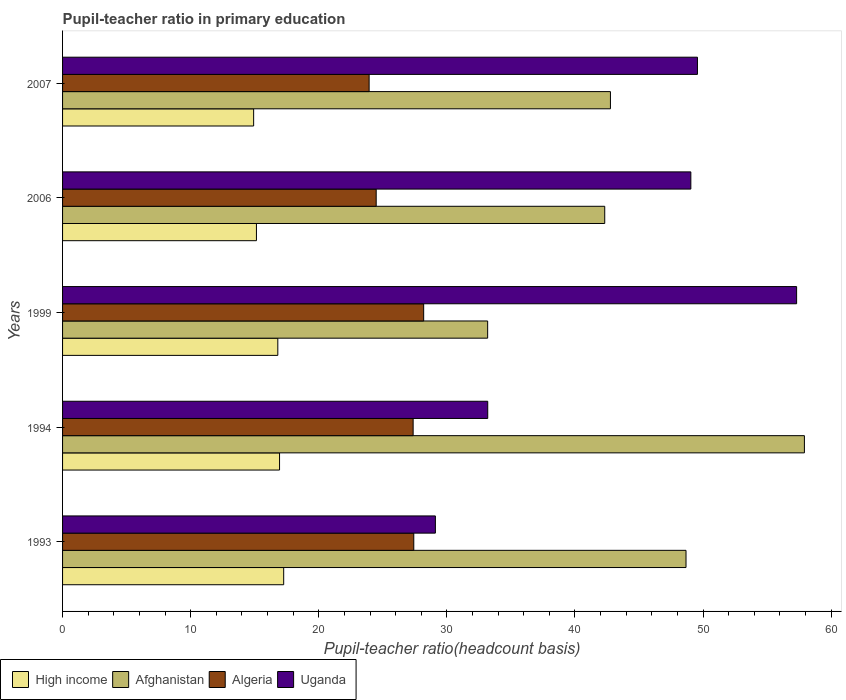How many different coloured bars are there?
Keep it short and to the point. 4. How many groups of bars are there?
Give a very brief answer. 5. What is the label of the 4th group of bars from the top?
Your answer should be very brief. 1994. In how many cases, is the number of bars for a given year not equal to the number of legend labels?
Your answer should be very brief. 0. What is the pupil-teacher ratio in primary education in High income in 2007?
Your answer should be very brief. 14.92. Across all years, what is the maximum pupil-teacher ratio in primary education in Afghanistan?
Your answer should be compact. 57.91. Across all years, what is the minimum pupil-teacher ratio in primary education in Uganda?
Keep it short and to the point. 29.11. In which year was the pupil-teacher ratio in primary education in Algeria maximum?
Your answer should be compact. 1999. In which year was the pupil-teacher ratio in primary education in Afghanistan minimum?
Offer a very short reply. 1999. What is the total pupil-teacher ratio in primary education in Uganda in the graph?
Provide a succinct answer. 218.21. What is the difference between the pupil-teacher ratio in primary education in Uganda in 1994 and that in 2006?
Your answer should be compact. -15.86. What is the difference between the pupil-teacher ratio in primary education in Uganda in 1993 and the pupil-teacher ratio in primary education in Algeria in 2007?
Offer a terse response. 5.17. What is the average pupil-teacher ratio in primary education in High income per year?
Your response must be concise. 16.21. In the year 2007, what is the difference between the pupil-teacher ratio in primary education in Uganda and pupil-teacher ratio in primary education in High income?
Make the answer very short. 34.65. What is the ratio of the pupil-teacher ratio in primary education in High income in 1994 to that in 2006?
Your answer should be very brief. 1.12. What is the difference between the highest and the second highest pupil-teacher ratio in primary education in High income?
Offer a terse response. 0.32. What is the difference between the highest and the lowest pupil-teacher ratio in primary education in High income?
Give a very brief answer. 2.35. Is the sum of the pupil-teacher ratio in primary education in Algeria in 1994 and 1999 greater than the maximum pupil-teacher ratio in primary education in Uganda across all years?
Your answer should be compact. No. Is it the case that in every year, the sum of the pupil-teacher ratio in primary education in High income and pupil-teacher ratio in primary education in Uganda is greater than the sum of pupil-teacher ratio in primary education in Algeria and pupil-teacher ratio in primary education in Afghanistan?
Your response must be concise. Yes. What does the 1st bar from the top in 1993 represents?
Your response must be concise. Uganda. What does the 1st bar from the bottom in 2007 represents?
Give a very brief answer. High income. Is it the case that in every year, the sum of the pupil-teacher ratio in primary education in Algeria and pupil-teacher ratio in primary education in Afghanistan is greater than the pupil-teacher ratio in primary education in High income?
Your answer should be compact. Yes. How many bars are there?
Offer a very short reply. 20. Are all the bars in the graph horizontal?
Offer a terse response. Yes. What is the difference between two consecutive major ticks on the X-axis?
Your answer should be compact. 10. Are the values on the major ticks of X-axis written in scientific E-notation?
Offer a very short reply. No. Does the graph contain any zero values?
Make the answer very short. No. Does the graph contain grids?
Your answer should be compact. No. How many legend labels are there?
Provide a succinct answer. 4. How are the legend labels stacked?
Provide a short and direct response. Horizontal. What is the title of the graph?
Give a very brief answer. Pupil-teacher ratio in primary education. What is the label or title of the X-axis?
Provide a short and direct response. Pupil-teacher ratio(headcount basis). What is the label or title of the Y-axis?
Keep it short and to the point. Years. What is the Pupil-teacher ratio(headcount basis) of High income in 1993?
Provide a short and direct response. 17.26. What is the Pupil-teacher ratio(headcount basis) of Afghanistan in 1993?
Your answer should be very brief. 48.67. What is the Pupil-teacher ratio(headcount basis) in Algeria in 1993?
Give a very brief answer. 27.42. What is the Pupil-teacher ratio(headcount basis) in Uganda in 1993?
Provide a succinct answer. 29.11. What is the Pupil-teacher ratio(headcount basis) in High income in 1994?
Offer a terse response. 16.94. What is the Pupil-teacher ratio(headcount basis) of Afghanistan in 1994?
Ensure brevity in your answer.  57.91. What is the Pupil-teacher ratio(headcount basis) in Algeria in 1994?
Provide a short and direct response. 27.37. What is the Pupil-teacher ratio(headcount basis) of Uganda in 1994?
Offer a very short reply. 33.19. What is the Pupil-teacher ratio(headcount basis) in High income in 1999?
Your answer should be compact. 16.8. What is the Pupil-teacher ratio(headcount basis) in Afghanistan in 1999?
Offer a terse response. 33.19. What is the Pupil-teacher ratio(headcount basis) of Algeria in 1999?
Keep it short and to the point. 28.19. What is the Pupil-teacher ratio(headcount basis) in Uganda in 1999?
Offer a very short reply. 57.3. What is the Pupil-teacher ratio(headcount basis) in High income in 2006?
Offer a terse response. 15.14. What is the Pupil-teacher ratio(headcount basis) in Afghanistan in 2006?
Make the answer very short. 42.33. What is the Pupil-teacher ratio(headcount basis) in Algeria in 2006?
Ensure brevity in your answer.  24.48. What is the Pupil-teacher ratio(headcount basis) in Uganda in 2006?
Give a very brief answer. 49.05. What is the Pupil-teacher ratio(headcount basis) in High income in 2007?
Provide a succinct answer. 14.92. What is the Pupil-teacher ratio(headcount basis) of Afghanistan in 2007?
Keep it short and to the point. 42.77. What is the Pupil-teacher ratio(headcount basis) of Algeria in 2007?
Offer a terse response. 23.93. What is the Pupil-teacher ratio(headcount basis) of Uganda in 2007?
Give a very brief answer. 49.56. Across all years, what is the maximum Pupil-teacher ratio(headcount basis) in High income?
Your answer should be very brief. 17.26. Across all years, what is the maximum Pupil-teacher ratio(headcount basis) in Afghanistan?
Keep it short and to the point. 57.91. Across all years, what is the maximum Pupil-teacher ratio(headcount basis) of Algeria?
Provide a short and direct response. 28.19. Across all years, what is the maximum Pupil-teacher ratio(headcount basis) in Uganda?
Provide a short and direct response. 57.3. Across all years, what is the minimum Pupil-teacher ratio(headcount basis) of High income?
Provide a succinct answer. 14.92. Across all years, what is the minimum Pupil-teacher ratio(headcount basis) of Afghanistan?
Your answer should be compact. 33.19. Across all years, what is the minimum Pupil-teacher ratio(headcount basis) of Algeria?
Give a very brief answer. 23.93. Across all years, what is the minimum Pupil-teacher ratio(headcount basis) in Uganda?
Offer a very short reply. 29.11. What is the total Pupil-teacher ratio(headcount basis) of High income in the graph?
Offer a very short reply. 81.06. What is the total Pupil-teacher ratio(headcount basis) in Afghanistan in the graph?
Your answer should be compact. 224.87. What is the total Pupil-teacher ratio(headcount basis) in Algeria in the graph?
Your response must be concise. 131.39. What is the total Pupil-teacher ratio(headcount basis) in Uganda in the graph?
Give a very brief answer. 218.21. What is the difference between the Pupil-teacher ratio(headcount basis) of High income in 1993 and that in 1994?
Make the answer very short. 0.32. What is the difference between the Pupil-teacher ratio(headcount basis) of Afghanistan in 1993 and that in 1994?
Your response must be concise. -9.24. What is the difference between the Pupil-teacher ratio(headcount basis) of Algeria in 1993 and that in 1994?
Keep it short and to the point. 0.05. What is the difference between the Pupil-teacher ratio(headcount basis) of Uganda in 1993 and that in 1994?
Offer a very short reply. -4.09. What is the difference between the Pupil-teacher ratio(headcount basis) in High income in 1993 and that in 1999?
Give a very brief answer. 0.46. What is the difference between the Pupil-teacher ratio(headcount basis) of Afghanistan in 1993 and that in 1999?
Your response must be concise. 15.49. What is the difference between the Pupil-teacher ratio(headcount basis) in Algeria in 1993 and that in 1999?
Your answer should be very brief. -0.77. What is the difference between the Pupil-teacher ratio(headcount basis) of Uganda in 1993 and that in 1999?
Your answer should be compact. -28.2. What is the difference between the Pupil-teacher ratio(headcount basis) in High income in 1993 and that in 2006?
Your answer should be compact. 2.13. What is the difference between the Pupil-teacher ratio(headcount basis) of Afghanistan in 1993 and that in 2006?
Provide a succinct answer. 6.35. What is the difference between the Pupil-teacher ratio(headcount basis) in Algeria in 1993 and that in 2006?
Keep it short and to the point. 2.93. What is the difference between the Pupil-teacher ratio(headcount basis) in Uganda in 1993 and that in 2006?
Your answer should be very brief. -19.94. What is the difference between the Pupil-teacher ratio(headcount basis) in High income in 1993 and that in 2007?
Offer a terse response. 2.35. What is the difference between the Pupil-teacher ratio(headcount basis) of Afghanistan in 1993 and that in 2007?
Keep it short and to the point. 5.9. What is the difference between the Pupil-teacher ratio(headcount basis) of Algeria in 1993 and that in 2007?
Provide a short and direct response. 3.49. What is the difference between the Pupil-teacher ratio(headcount basis) of Uganda in 1993 and that in 2007?
Keep it short and to the point. -20.46. What is the difference between the Pupil-teacher ratio(headcount basis) in High income in 1994 and that in 1999?
Give a very brief answer. 0.14. What is the difference between the Pupil-teacher ratio(headcount basis) in Afghanistan in 1994 and that in 1999?
Make the answer very short. 24.73. What is the difference between the Pupil-teacher ratio(headcount basis) of Algeria in 1994 and that in 1999?
Offer a terse response. -0.82. What is the difference between the Pupil-teacher ratio(headcount basis) of Uganda in 1994 and that in 1999?
Your answer should be very brief. -24.11. What is the difference between the Pupil-teacher ratio(headcount basis) of High income in 1994 and that in 2006?
Your answer should be compact. 1.8. What is the difference between the Pupil-teacher ratio(headcount basis) of Afghanistan in 1994 and that in 2006?
Provide a short and direct response. 15.59. What is the difference between the Pupil-teacher ratio(headcount basis) of Algeria in 1994 and that in 2006?
Provide a succinct answer. 2.88. What is the difference between the Pupil-teacher ratio(headcount basis) of Uganda in 1994 and that in 2006?
Provide a short and direct response. -15.86. What is the difference between the Pupil-teacher ratio(headcount basis) of High income in 1994 and that in 2007?
Ensure brevity in your answer.  2.02. What is the difference between the Pupil-teacher ratio(headcount basis) of Afghanistan in 1994 and that in 2007?
Offer a terse response. 15.14. What is the difference between the Pupil-teacher ratio(headcount basis) of Algeria in 1994 and that in 2007?
Your response must be concise. 3.44. What is the difference between the Pupil-teacher ratio(headcount basis) in Uganda in 1994 and that in 2007?
Your response must be concise. -16.37. What is the difference between the Pupil-teacher ratio(headcount basis) of High income in 1999 and that in 2006?
Make the answer very short. 1.67. What is the difference between the Pupil-teacher ratio(headcount basis) in Afghanistan in 1999 and that in 2006?
Provide a succinct answer. -9.14. What is the difference between the Pupil-teacher ratio(headcount basis) of Algeria in 1999 and that in 2006?
Make the answer very short. 3.71. What is the difference between the Pupil-teacher ratio(headcount basis) of Uganda in 1999 and that in 2006?
Keep it short and to the point. 8.26. What is the difference between the Pupil-teacher ratio(headcount basis) of High income in 1999 and that in 2007?
Your response must be concise. 1.89. What is the difference between the Pupil-teacher ratio(headcount basis) of Afghanistan in 1999 and that in 2007?
Offer a terse response. -9.58. What is the difference between the Pupil-teacher ratio(headcount basis) in Algeria in 1999 and that in 2007?
Keep it short and to the point. 4.26. What is the difference between the Pupil-teacher ratio(headcount basis) in Uganda in 1999 and that in 2007?
Provide a short and direct response. 7.74. What is the difference between the Pupil-teacher ratio(headcount basis) of High income in 2006 and that in 2007?
Ensure brevity in your answer.  0.22. What is the difference between the Pupil-teacher ratio(headcount basis) of Afghanistan in 2006 and that in 2007?
Offer a terse response. -0.44. What is the difference between the Pupil-teacher ratio(headcount basis) of Algeria in 2006 and that in 2007?
Offer a very short reply. 0.55. What is the difference between the Pupil-teacher ratio(headcount basis) of Uganda in 2006 and that in 2007?
Your response must be concise. -0.52. What is the difference between the Pupil-teacher ratio(headcount basis) of High income in 1993 and the Pupil-teacher ratio(headcount basis) of Afghanistan in 1994?
Offer a terse response. -40.65. What is the difference between the Pupil-teacher ratio(headcount basis) of High income in 1993 and the Pupil-teacher ratio(headcount basis) of Algeria in 1994?
Keep it short and to the point. -10.11. What is the difference between the Pupil-teacher ratio(headcount basis) in High income in 1993 and the Pupil-teacher ratio(headcount basis) in Uganda in 1994?
Offer a very short reply. -15.93. What is the difference between the Pupil-teacher ratio(headcount basis) of Afghanistan in 1993 and the Pupil-teacher ratio(headcount basis) of Algeria in 1994?
Offer a very short reply. 21.3. What is the difference between the Pupil-teacher ratio(headcount basis) of Afghanistan in 1993 and the Pupil-teacher ratio(headcount basis) of Uganda in 1994?
Your response must be concise. 15.48. What is the difference between the Pupil-teacher ratio(headcount basis) of Algeria in 1993 and the Pupil-teacher ratio(headcount basis) of Uganda in 1994?
Your response must be concise. -5.77. What is the difference between the Pupil-teacher ratio(headcount basis) in High income in 1993 and the Pupil-teacher ratio(headcount basis) in Afghanistan in 1999?
Offer a very short reply. -15.92. What is the difference between the Pupil-teacher ratio(headcount basis) of High income in 1993 and the Pupil-teacher ratio(headcount basis) of Algeria in 1999?
Ensure brevity in your answer.  -10.93. What is the difference between the Pupil-teacher ratio(headcount basis) of High income in 1993 and the Pupil-teacher ratio(headcount basis) of Uganda in 1999?
Offer a terse response. -40.04. What is the difference between the Pupil-teacher ratio(headcount basis) in Afghanistan in 1993 and the Pupil-teacher ratio(headcount basis) in Algeria in 1999?
Make the answer very short. 20.48. What is the difference between the Pupil-teacher ratio(headcount basis) of Afghanistan in 1993 and the Pupil-teacher ratio(headcount basis) of Uganda in 1999?
Give a very brief answer. -8.63. What is the difference between the Pupil-teacher ratio(headcount basis) of Algeria in 1993 and the Pupil-teacher ratio(headcount basis) of Uganda in 1999?
Keep it short and to the point. -29.89. What is the difference between the Pupil-teacher ratio(headcount basis) in High income in 1993 and the Pupil-teacher ratio(headcount basis) in Afghanistan in 2006?
Provide a short and direct response. -25.06. What is the difference between the Pupil-teacher ratio(headcount basis) in High income in 1993 and the Pupil-teacher ratio(headcount basis) in Algeria in 2006?
Your response must be concise. -7.22. What is the difference between the Pupil-teacher ratio(headcount basis) of High income in 1993 and the Pupil-teacher ratio(headcount basis) of Uganda in 2006?
Your response must be concise. -31.78. What is the difference between the Pupil-teacher ratio(headcount basis) of Afghanistan in 1993 and the Pupil-teacher ratio(headcount basis) of Algeria in 2006?
Your answer should be very brief. 24.19. What is the difference between the Pupil-teacher ratio(headcount basis) in Afghanistan in 1993 and the Pupil-teacher ratio(headcount basis) in Uganda in 2006?
Ensure brevity in your answer.  -0.38. What is the difference between the Pupil-teacher ratio(headcount basis) of Algeria in 1993 and the Pupil-teacher ratio(headcount basis) of Uganda in 2006?
Ensure brevity in your answer.  -21.63. What is the difference between the Pupil-teacher ratio(headcount basis) of High income in 1993 and the Pupil-teacher ratio(headcount basis) of Afghanistan in 2007?
Your response must be concise. -25.51. What is the difference between the Pupil-teacher ratio(headcount basis) of High income in 1993 and the Pupil-teacher ratio(headcount basis) of Algeria in 2007?
Your response must be concise. -6.67. What is the difference between the Pupil-teacher ratio(headcount basis) of High income in 1993 and the Pupil-teacher ratio(headcount basis) of Uganda in 2007?
Give a very brief answer. -32.3. What is the difference between the Pupil-teacher ratio(headcount basis) of Afghanistan in 1993 and the Pupil-teacher ratio(headcount basis) of Algeria in 2007?
Your answer should be compact. 24.74. What is the difference between the Pupil-teacher ratio(headcount basis) in Afghanistan in 1993 and the Pupil-teacher ratio(headcount basis) in Uganda in 2007?
Offer a very short reply. -0.89. What is the difference between the Pupil-teacher ratio(headcount basis) of Algeria in 1993 and the Pupil-teacher ratio(headcount basis) of Uganda in 2007?
Offer a terse response. -22.15. What is the difference between the Pupil-teacher ratio(headcount basis) of High income in 1994 and the Pupil-teacher ratio(headcount basis) of Afghanistan in 1999?
Offer a very short reply. -16.25. What is the difference between the Pupil-teacher ratio(headcount basis) of High income in 1994 and the Pupil-teacher ratio(headcount basis) of Algeria in 1999?
Your response must be concise. -11.25. What is the difference between the Pupil-teacher ratio(headcount basis) in High income in 1994 and the Pupil-teacher ratio(headcount basis) in Uganda in 1999?
Provide a short and direct response. -40.37. What is the difference between the Pupil-teacher ratio(headcount basis) in Afghanistan in 1994 and the Pupil-teacher ratio(headcount basis) in Algeria in 1999?
Provide a short and direct response. 29.72. What is the difference between the Pupil-teacher ratio(headcount basis) in Afghanistan in 1994 and the Pupil-teacher ratio(headcount basis) in Uganda in 1999?
Ensure brevity in your answer.  0.61. What is the difference between the Pupil-teacher ratio(headcount basis) in Algeria in 1994 and the Pupil-teacher ratio(headcount basis) in Uganda in 1999?
Your response must be concise. -29.94. What is the difference between the Pupil-teacher ratio(headcount basis) of High income in 1994 and the Pupil-teacher ratio(headcount basis) of Afghanistan in 2006?
Your answer should be compact. -25.39. What is the difference between the Pupil-teacher ratio(headcount basis) of High income in 1994 and the Pupil-teacher ratio(headcount basis) of Algeria in 2006?
Give a very brief answer. -7.54. What is the difference between the Pupil-teacher ratio(headcount basis) of High income in 1994 and the Pupil-teacher ratio(headcount basis) of Uganda in 2006?
Provide a short and direct response. -32.11. What is the difference between the Pupil-teacher ratio(headcount basis) in Afghanistan in 1994 and the Pupil-teacher ratio(headcount basis) in Algeria in 2006?
Offer a very short reply. 33.43. What is the difference between the Pupil-teacher ratio(headcount basis) in Afghanistan in 1994 and the Pupil-teacher ratio(headcount basis) in Uganda in 2006?
Offer a terse response. 8.87. What is the difference between the Pupil-teacher ratio(headcount basis) in Algeria in 1994 and the Pupil-teacher ratio(headcount basis) in Uganda in 2006?
Provide a short and direct response. -21.68. What is the difference between the Pupil-teacher ratio(headcount basis) in High income in 1994 and the Pupil-teacher ratio(headcount basis) in Afghanistan in 2007?
Offer a very short reply. -25.83. What is the difference between the Pupil-teacher ratio(headcount basis) in High income in 1994 and the Pupil-teacher ratio(headcount basis) in Algeria in 2007?
Provide a succinct answer. -6.99. What is the difference between the Pupil-teacher ratio(headcount basis) of High income in 1994 and the Pupil-teacher ratio(headcount basis) of Uganda in 2007?
Ensure brevity in your answer.  -32.62. What is the difference between the Pupil-teacher ratio(headcount basis) in Afghanistan in 1994 and the Pupil-teacher ratio(headcount basis) in Algeria in 2007?
Offer a terse response. 33.98. What is the difference between the Pupil-teacher ratio(headcount basis) of Afghanistan in 1994 and the Pupil-teacher ratio(headcount basis) of Uganda in 2007?
Offer a terse response. 8.35. What is the difference between the Pupil-teacher ratio(headcount basis) of Algeria in 1994 and the Pupil-teacher ratio(headcount basis) of Uganda in 2007?
Offer a terse response. -22.2. What is the difference between the Pupil-teacher ratio(headcount basis) in High income in 1999 and the Pupil-teacher ratio(headcount basis) in Afghanistan in 2006?
Ensure brevity in your answer.  -25.52. What is the difference between the Pupil-teacher ratio(headcount basis) of High income in 1999 and the Pupil-teacher ratio(headcount basis) of Algeria in 2006?
Offer a terse response. -7.68. What is the difference between the Pupil-teacher ratio(headcount basis) in High income in 1999 and the Pupil-teacher ratio(headcount basis) in Uganda in 2006?
Your answer should be compact. -32.24. What is the difference between the Pupil-teacher ratio(headcount basis) of Afghanistan in 1999 and the Pupil-teacher ratio(headcount basis) of Algeria in 2006?
Your answer should be very brief. 8.7. What is the difference between the Pupil-teacher ratio(headcount basis) in Afghanistan in 1999 and the Pupil-teacher ratio(headcount basis) in Uganda in 2006?
Offer a terse response. -15.86. What is the difference between the Pupil-teacher ratio(headcount basis) in Algeria in 1999 and the Pupil-teacher ratio(headcount basis) in Uganda in 2006?
Keep it short and to the point. -20.86. What is the difference between the Pupil-teacher ratio(headcount basis) of High income in 1999 and the Pupil-teacher ratio(headcount basis) of Afghanistan in 2007?
Your answer should be very brief. -25.97. What is the difference between the Pupil-teacher ratio(headcount basis) in High income in 1999 and the Pupil-teacher ratio(headcount basis) in Algeria in 2007?
Your answer should be compact. -7.13. What is the difference between the Pupil-teacher ratio(headcount basis) of High income in 1999 and the Pupil-teacher ratio(headcount basis) of Uganda in 2007?
Make the answer very short. -32.76. What is the difference between the Pupil-teacher ratio(headcount basis) of Afghanistan in 1999 and the Pupil-teacher ratio(headcount basis) of Algeria in 2007?
Keep it short and to the point. 9.25. What is the difference between the Pupil-teacher ratio(headcount basis) of Afghanistan in 1999 and the Pupil-teacher ratio(headcount basis) of Uganda in 2007?
Provide a succinct answer. -16.38. What is the difference between the Pupil-teacher ratio(headcount basis) in Algeria in 1999 and the Pupil-teacher ratio(headcount basis) in Uganda in 2007?
Provide a succinct answer. -21.37. What is the difference between the Pupil-teacher ratio(headcount basis) in High income in 2006 and the Pupil-teacher ratio(headcount basis) in Afghanistan in 2007?
Your response must be concise. -27.64. What is the difference between the Pupil-teacher ratio(headcount basis) in High income in 2006 and the Pupil-teacher ratio(headcount basis) in Algeria in 2007?
Make the answer very short. -8.8. What is the difference between the Pupil-teacher ratio(headcount basis) in High income in 2006 and the Pupil-teacher ratio(headcount basis) in Uganda in 2007?
Make the answer very short. -34.43. What is the difference between the Pupil-teacher ratio(headcount basis) of Afghanistan in 2006 and the Pupil-teacher ratio(headcount basis) of Algeria in 2007?
Your answer should be very brief. 18.39. What is the difference between the Pupil-teacher ratio(headcount basis) in Afghanistan in 2006 and the Pupil-teacher ratio(headcount basis) in Uganda in 2007?
Your answer should be very brief. -7.24. What is the difference between the Pupil-teacher ratio(headcount basis) in Algeria in 2006 and the Pupil-teacher ratio(headcount basis) in Uganda in 2007?
Your answer should be very brief. -25.08. What is the average Pupil-teacher ratio(headcount basis) of High income per year?
Make the answer very short. 16.21. What is the average Pupil-teacher ratio(headcount basis) in Afghanistan per year?
Your answer should be compact. 44.97. What is the average Pupil-teacher ratio(headcount basis) in Algeria per year?
Your answer should be very brief. 26.28. What is the average Pupil-teacher ratio(headcount basis) of Uganda per year?
Offer a very short reply. 43.64. In the year 1993, what is the difference between the Pupil-teacher ratio(headcount basis) in High income and Pupil-teacher ratio(headcount basis) in Afghanistan?
Offer a very short reply. -31.41. In the year 1993, what is the difference between the Pupil-teacher ratio(headcount basis) of High income and Pupil-teacher ratio(headcount basis) of Algeria?
Provide a succinct answer. -10.16. In the year 1993, what is the difference between the Pupil-teacher ratio(headcount basis) of High income and Pupil-teacher ratio(headcount basis) of Uganda?
Your answer should be compact. -11.84. In the year 1993, what is the difference between the Pupil-teacher ratio(headcount basis) of Afghanistan and Pupil-teacher ratio(headcount basis) of Algeria?
Your answer should be very brief. 21.25. In the year 1993, what is the difference between the Pupil-teacher ratio(headcount basis) of Afghanistan and Pupil-teacher ratio(headcount basis) of Uganda?
Provide a short and direct response. 19.57. In the year 1993, what is the difference between the Pupil-teacher ratio(headcount basis) in Algeria and Pupil-teacher ratio(headcount basis) in Uganda?
Your answer should be very brief. -1.69. In the year 1994, what is the difference between the Pupil-teacher ratio(headcount basis) in High income and Pupil-teacher ratio(headcount basis) in Afghanistan?
Provide a succinct answer. -40.97. In the year 1994, what is the difference between the Pupil-teacher ratio(headcount basis) of High income and Pupil-teacher ratio(headcount basis) of Algeria?
Make the answer very short. -10.43. In the year 1994, what is the difference between the Pupil-teacher ratio(headcount basis) of High income and Pupil-teacher ratio(headcount basis) of Uganda?
Provide a short and direct response. -16.25. In the year 1994, what is the difference between the Pupil-teacher ratio(headcount basis) in Afghanistan and Pupil-teacher ratio(headcount basis) in Algeria?
Offer a terse response. 30.54. In the year 1994, what is the difference between the Pupil-teacher ratio(headcount basis) in Afghanistan and Pupil-teacher ratio(headcount basis) in Uganda?
Provide a short and direct response. 24.72. In the year 1994, what is the difference between the Pupil-teacher ratio(headcount basis) in Algeria and Pupil-teacher ratio(headcount basis) in Uganda?
Provide a short and direct response. -5.82. In the year 1999, what is the difference between the Pupil-teacher ratio(headcount basis) of High income and Pupil-teacher ratio(headcount basis) of Afghanistan?
Provide a succinct answer. -16.38. In the year 1999, what is the difference between the Pupil-teacher ratio(headcount basis) in High income and Pupil-teacher ratio(headcount basis) in Algeria?
Make the answer very short. -11.39. In the year 1999, what is the difference between the Pupil-teacher ratio(headcount basis) of High income and Pupil-teacher ratio(headcount basis) of Uganda?
Make the answer very short. -40.5. In the year 1999, what is the difference between the Pupil-teacher ratio(headcount basis) of Afghanistan and Pupil-teacher ratio(headcount basis) of Algeria?
Provide a succinct answer. 5. In the year 1999, what is the difference between the Pupil-teacher ratio(headcount basis) of Afghanistan and Pupil-teacher ratio(headcount basis) of Uganda?
Offer a terse response. -24.12. In the year 1999, what is the difference between the Pupil-teacher ratio(headcount basis) in Algeria and Pupil-teacher ratio(headcount basis) in Uganda?
Provide a short and direct response. -29.11. In the year 2006, what is the difference between the Pupil-teacher ratio(headcount basis) of High income and Pupil-teacher ratio(headcount basis) of Afghanistan?
Offer a very short reply. -27.19. In the year 2006, what is the difference between the Pupil-teacher ratio(headcount basis) of High income and Pupil-teacher ratio(headcount basis) of Algeria?
Provide a short and direct response. -9.35. In the year 2006, what is the difference between the Pupil-teacher ratio(headcount basis) of High income and Pupil-teacher ratio(headcount basis) of Uganda?
Provide a short and direct response. -33.91. In the year 2006, what is the difference between the Pupil-teacher ratio(headcount basis) of Afghanistan and Pupil-teacher ratio(headcount basis) of Algeria?
Offer a very short reply. 17.84. In the year 2006, what is the difference between the Pupil-teacher ratio(headcount basis) in Afghanistan and Pupil-teacher ratio(headcount basis) in Uganda?
Provide a short and direct response. -6.72. In the year 2006, what is the difference between the Pupil-teacher ratio(headcount basis) in Algeria and Pupil-teacher ratio(headcount basis) in Uganda?
Give a very brief answer. -24.56. In the year 2007, what is the difference between the Pupil-teacher ratio(headcount basis) in High income and Pupil-teacher ratio(headcount basis) in Afghanistan?
Your response must be concise. -27.85. In the year 2007, what is the difference between the Pupil-teacher ratio(headcount basis) of High income and Pupil-teacher ratio(headcount basis) of Algeria?
Your answer should be compact. -9.02. In the year 2007, what is the difference between the Pupil-teacher ratio(headcount basis) in High income and Pupil-teacher ratio(headcount basis) in Uganda?
Make the answer very short. -34.65. In the year 2007, what is the difference between the Pupil-teacher ratio(headcount basis) in Afghanistan and Pupil-teacher ratio(headcount basis) in Algeria?
Provide a short and direct response. 18.84. In the year 2007, what is the difference between the Pupil-teacher ratio(headcount basis) in Afghanistan and Pupil-teacher ratio(headcount basis) in Uganda?
Give a very brief answer. -6.79. In the year 2007, what is the difference between the Pupil-teacher ratio(headcount basis) of Algeria and Pupil-teacher ratio(headcount basis) of Uganda?
Give a very brief answer. -25.63. What is the ratio of the Pupil-teacher ratio(headcount basis) of High income in 1993 to that in 1994?
Make the answer very short. 1.02. What is the ratio of the Pupil-teacher ratio(headcount basis) in Afghanistan in 1993 to that in 1994?
Offer a very short reply. 0.84. What is the ratio of the Pupil-teacher ratio(headcount basis) of Uganda in 1993 to that in 1994?
Provide a short and direct response. 0.88. What is the ratio of the Pupil-teacher ratio(headcount basis) of High income in 1993 to that in 1999?
Your response must be concise. 1.03. What is the ratio of the Pupil-teacher ratio(headcount basis) of Afghanistan in 1993 to that in 1999?
Keep it short and to the point. 1.47. What is the ratio of the Pupil-teacher ratio(headcount basis) of Algeria in 1993 to that in 1999?
Provide a short and direct response. 0.97. What is the ratio of the Pupil-teacher ratio(headcount basis) of Uganda in 1993 to that in 1999?
Keep it short and to the point. 0.51. What is the ratio of the Pupil-teacher ratio(headcount basis) in High income in 1993 to that in 2006?
Give a very brief answer. 1.14. What is the ratio of the Pupil-teacher ratio(headcount basis) of Afghanistan in 1993 to that in 2006?
Your answer should be compact. 1.15. What is the ratio of the Pupil-teacher ratio(headcount basis) of Algeria in 1993 to that in 2006?
Make the answer very short. 1.12. What is the ratio of the Pupil-teacher ratio(headcount basis) in Uganda in 1993 to that in 2006?
Offer a terse response. 0.59. What is the ratio of the Pupil-teacher ratio(headcount basis) in High income in 1993 to that in 2007?
Keep it short and to the point. 1.16. What is the ratio of the Pupil-teacher ratio(headcount basis) in Afghanistan in 1993 to that in 2007?
Your answer should be very brief. 1.14. What is the ratio of the Pupil-teacher ratio(headcount basis) of Algeria in 1993 to that in 2007?
Provide a short and direct response. 1.15. What is the ratio of the Pupil-teacher ratio(headcount basis) in Uganda in 1993 to that in 2007?
Make the answer very short. 0.59. What is the ratio of the Pupil-teacher ratio(headcount basis) in Afghanistan in 1994 to that in 1999?
Offer a terse response. 1.75. What is the ratio of the Pupil-teacher ratio(headcount basis) in Algeria in 1994 to that in 1999?
Ensure brevity in your answer.  0.97. What is the ratio of the Pupil-teacher ratio(headcount basis) of Uganda in 1994 to that in 1999?
Offer a very short reply. 0.58. What is the ratio of the Pupil-teacher ratio(headcount basis) of High income in 1994 to that in 2006?
Ensure brevity in your answer.  1.12. What is the ratio of the Pupil-teacher ratio(headcount basis) of Afghanistan in 1994 to that in 2006?
Your response must be concise. 1.37. What is the ratio of the Pupil-teacher ratio(headcount basis) of Algeria in 1994 to that in 2006?
Your answer should be compact. 1.12. What is the ratio of the Pupil-teacher ratio(headcount basis) of Uganda in 1994 to that in 2006?
Your answer should be very brief. 0.68. What is the ratio of the Pupil-teacher ratio(headcount basis) of High income in 1994 to that in 2007?
Keep it short and to the point. 1.14. What is the ratio of the Pupil-teacher ratio(headcount basis) in Afghanistan in 1994 to that in 2007?
Keep it short and to the point. 1.35. What is the ratio of the Pupil-teacher ratio(headcount basis) in Algeria in 1994 to that in 2007?
Your response must be concise. 1.14. What is the ratio of the Pupil-teacher ratio(headcount basis) of Uganda in 1994 to that in 2007?
Provide a succinct answer. 0.67. What is the ratio of the Pupil-teacher ratio(headcount basis) in High income in 1999 to that in 2006?
Your response must be concise. 1.11. What is the ratio of the Pupil-teacher ratio(headcount basis) in Afghanistan in 1999 to that in 2006?
Offer a very short reply. 0.78. What is the ratio of the Pupil-teacher ratio(headcount basis) in Algeria in 1999 to that in 2006?
Give a very brief answer. 1.15. What is the ratio of the Pupil-teacher ratio(headcount basis) of Uganda in 1999 to that in 2006?
Offer a terse response. 1.17. What is the ratio of the Pupil-teacher ratio(headcount basis) of High income in 1999 to that in 2007?
Offer a very short reply. 1.13. What is the ratio of the Pupil-teacher ratio(headcount basis) of Afghanistan in 1999 to that in 2007?
Keep it short and to the point. 0.78. What is the ratio of the Pupil-teacher ratio(headcount basis) of Algeria in 1999 to that in 2007?
Your response must be concise. 1.18. What is the ratio of the Pupil-teacher ratio(headcount basis) in Uganda in 1999 to that in 2007?
Your answer should be compact. 1.16. What is the ratio of the Pupil-teacher ratio(headcount basis) of High income in 2006 to that in 2007?
Provide a short and direct response. 1.01. What is the ratio of the Pupil-teacher ratio(headcount basis) in Afghanistan in 2006 to that in 2007?
Your answer should be very brief. 0.99. What is the ratio of the Pupil-teacher ratio(headcount basis) in Algeria in 2006 to that in 2007?
Make the answer very short. 1.02. What is the ratio of the Pupil-teacher ratio(headcount basis) of Uganda in 2006 to that in 2007?
Keep it short and to the point. 0.99. What is the difference between the highest and the second highest Pupil-teacher ratio(headcount basis) in High income?
Give a very brief answer. 0.32. What is the difference between the highest and the second highest Pupil-teacher ratio(headcount basis) of Afghanistan?
Make the answer very short. 9.24. What is the difference between the highest and the second highest Pupil-teacher ratio(headcount basis) of Algeria?
Your answer should be compact. 0.77. What is the difference between the highest and the second highest Pupil-teacher ratio(headcount basis) of Uganda?
Your answer should be very brief. 7.74. What is the difference between the highest and the lowest Pupil-teacher ratio(headcount basis) of High income?
Make the answer very short. 2.35. What is the difference between the highest and the lowest Pupil-teacher ratio(headcount basis) of Afghanistan?
Ensure brevity in your answer.  24.73. What is the difference between the highest and the lowest Pupil-teacher ratio(headcount basis) in Algeria?
Provide a short and direct response. 4.26. What is the difference between the highest and the lowest Pupil-teacher ratio(headcount basis) in Uganda?
Give a very brief answer. 28.2. 